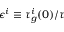<formula> <loc_0><loc_0><loc_500><loc_500>\epsilon ^ { i } \equiv \tau _ { g } ^ { i } ( 0 ) / \tau</formula> 